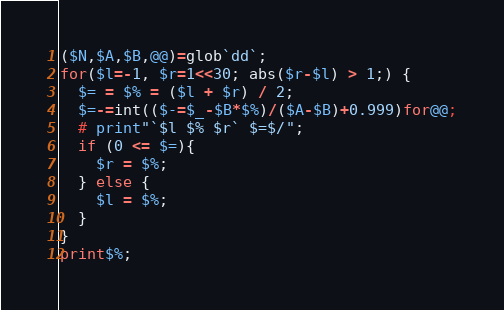Convert code to text. <code><loc_0><loc_0><loc_500><loc_500><_Perl_>($N,$A,$B,@@)=glob`dd`;
for($l=-1, $r=1<<30; abs($r-$l) > 1;) {
  $= = $% = ($l + $r) / 2;
  $=-=int(($-=$_-$B*$%)/($A-$B)+0.999)for@@;
  # print"`$l $% $r` $=$/";
  if (0 <= $=){
    $r = $%;
  } else {
    $l = $%;
  }
}
print$%;
</code> 